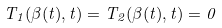<formula> <loc_0><loc_0><loc_500><loc_500>T _ { 1 } ( \beta ( t ) , t ) = T _ { 2 } ( \beta ( t ) , t ) = 0</formula> 